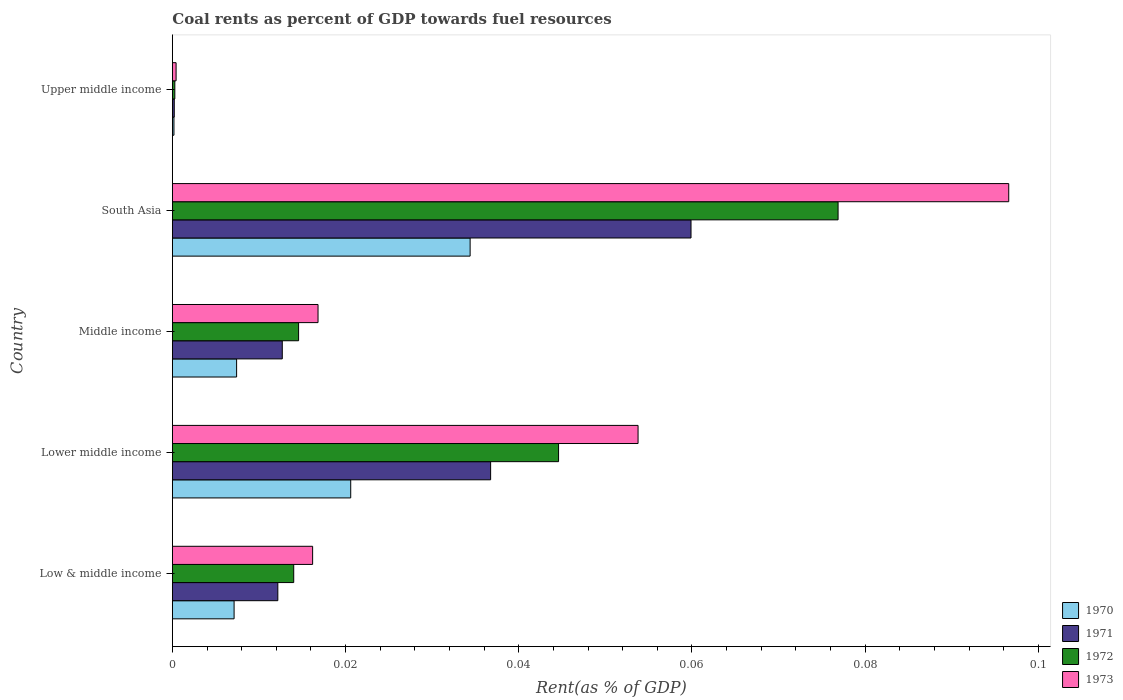Are the number of bars on each tick of the Y-axis equal?
Keep it short and to the point. Yes. How many bars are there on the 5th tick from the top?
Provide a short and direct response. 4. How many bars are there on the 1st tick from the bottom?
Provide a short and direct response. 4. What is the label of the 4th group of bars from the top?
Offer a terse response. Lower middle income. In how many cases, is the number of bars for a given country not equal to the number of legend labels?
Make the answer very short. 0. What is the coal rent in 1970 in Middle income?
Offer a terse response. 0.01. Across all countries, what is the maximum coal rent in 1973?
Provide a succinct answer. 0.1. Across all countries, what is the minimum coal rent in 1970?
Offer a very short reply. 0. In which country was the coal rent in 1971 maximum?
Offer a very short reply. South Asia. In which country was the coal rent in 1973 minimum?
Make the answer very short. Upper middle income. What is the total coal rent in 1973 in the graph?
Offer a very short reply. 0.18. What is the difference between the coal rent in 1971 in South Asia and that in Upper middle income?
Keep it short and to the point. 0.06. What is the difference between the coal rent in 1973 in Lower middle income and the coal rent in 1970 in Middle income?
Keep it short and to the point. 0.05. What is the average coal rent in 1970 per country?
Provide a short and direct response. 0.01. What is the difference between the coal rent in 1971 and coal rent in 1970 in Low & middle income?
Provide a succinct answer. 0.01. In how many countries, is the coal rent in 1971 greater than 0.008 %?
Your answer should be very brief. 4. What is the ratio of the coal rent in 1973 in Low & middle income to that in Lower middle income?
Make the answer very short. 0.3. What is the difference between the highest and the second highest coal rent in 1970?
Your answer should be compact. 0.01. What is the difference between the highest and the lowest coal rent in 1970?
Your response must be concise. 0.03. Is it the case that in every country, the sum of the coal rent in 1973 and coal rent in 1970 is greater than the sum of coal rent in 1971 and coal rent in 1972?
Keep it short and to the point. No. What does the 1st bar from the bottom in Upper middle income represents?
Your answer should be very brief. 1970. What is the difference between two consecutive major ticks on the X-axis?
Your answer should be very brief. 0.02. Does the graph contain any zero values?
Keep it short and to the point. No. Does the graph contain grids?
Your answer should be compact. No. Where does the legend appear in the graph?
Give a very brief answer. Bottom right. How many legend labels are there?
Your answer should be compact. 4. What is the title of the graph?
Your answer should be very brief. Coal rents as percent of GDP towards fuel resources. Does "2005" appear as one of the legend labels in the graph?
Your answer should be very brief. No. What is the label or title of the X-axis?
Make the answer very short. Rent(as % of GDP). What is the Rent(as % of GDP) of 1970 in Low & middle income?
Ensure brevity in your answer.  0.01. What is the Rent(as % of GDP) of 1971 in Low & middle income?
Your answer should be compact. 0.01. What is the Rent(as % of GDP) in 1972 in Low & middle income?
Your response must be concise. 0.01. What is the Rent(as % of GDP) in 1973 in Low & middle income?
Provide a short and direct response. 0.02. What is the Rent(as % of GDP) of 1970 in Lower middle income?
Your answer should be very brief. 0.02. What is the Rent(as % of GDP) in 1971 in Lower middle income?
Your answer should be compact. 0.04. What is the Rent(as % of GDP) of 1972 in Lower middle income?
Offer a very short reply. 0.04. What is the Rent(as % of GDP) of 1973 in Lower middle income?
Offer a terse response. 0.05. What is the Rent(as % of GDP) in 1970 in Middle income?
Give a very brief answer. 0.01. What is the Rent(as % of GDP) of 1971 in Middle income?
Provide a short and direct response. 0.01. What is the Rent(as % of GDP) of 1972 in Middle income?
Offer a very short reply. 0.01. What is the Rent(as % of GDP) in 1973 in Middle income?
Keep it short and to the point. 0.02. What is the Rent(as % of GDP) of 1970 in South Asia?
Your answer should be very brief. 0.03. What is the Rent(as % of GDP) in 1971 in South Asia?
Your response must be concise. 0.06. What is the Rent(as % of GDP) in 1972 in South Asia?
Make the answer very short. 0.08. What is the Rent(as % of GDP) in 1973 in South Asia?
Your response must be concise. 0.1. What is the Rent(as % of GDP) in 1970 in Upper middle income?
Keep it short and to the point. 0. What is the Rent(as % of GDP) in 1971 in Upper middle income?
Provide a short and direct response. 0. What is the Rent(as % of GDP) in 1972 in Upper middle income?
Your response must be concise. 0. What is the Rent(as % of GDP) in 1973 in Upper middle income?
Offer a very short reply. 0. Across all countries, what is the maximum Rent(as % of GDP) of 1970?
Your response must be concise. 0.03. Across all countries, what is the maximum Rent(as % of GDP) in 1971?
Keep it short and to the point. 0.06. Across all countries, what is the maximum Rent(as % of GDP) of 1972?
Offer a very short reply. 0.08. Across all countries, what is the maximum Rent(as % of GDP) in 1973?
Offer a very short reply. 0.1. Across all countries, what is the minimum Rent(as % of GDP) of 1970?
Offer a very short reply. 0. Across all countries, what is the minimum Rent(as % of GDP) of 1971?
Offer a very short reply. 0. Across all countries, what is the minimum Rent(as % of GDP) in 1972?
Your answer should be compact. 0. Across all countries, what is the minimum Rent(as % of GDP) of 1973?
Offer a very short reply. 0. What is the total Rent(as % of GDP) of 1970 in the graph?
Your answer should be very brief. 0.07. What is the total Rent(as % of GDP) of 1971 in the graph?
Provide a short and direct response. 0.12. What is the total Rent(as % of GDP) of 1972 in the graph?
Offer a terse response. 0.15. What is the total Rent(as % of GDP) in 1973 in the graph?
Offer a very short reply. 0.18. What is the difference between the Rent(as % of GDP) of 1970 in Low & middle income and that in Lower middle income?
Provide a short and direct response. -0.01. What is the difference between the Rent(as % of GDP) of 1971 in Low & middle income and that in Lower middle income?
Offer a terse response. -0.02. What is the difference between the Rent(as % of GDP) of 1972 in Low & middle income and that in Lower middle income?
Provide a short and direct response. -0.03. What is the difference between the Rent(as % of GDP) of 1973 in Low & middle income and that in Lower middle income?
Give a very brief answer. -0.04. What is the difference between the Rent(as % of GDP) of 1970 in Low & middle income and that in Middle income?
Provide a short and direct response. -0. What is the difference between the Rent(as % of GDP) of 1971 in Low & middle income and that in Middle income?
Your answer should be compact. -0. What is the difference between the Rent(as % of GDP) in 1972 in Low & middle income and that in Middle income?
Ensure brevity in your answer.  -0. What is the difference between the Rent(as % of GDP) of 1973 in Low & middle income and that in Middle income?
Make the answer very short. -0. What is the difference between the Rent(as % of GDP) in 1970 in Low & middle income and that in South Asia?
Give a very brief answer. -0.03. What is the difference between the Rent(as % of GDP) of 1971 in Low & middle income and that in South Asia?
Your answer should be compact. -0.05. What is the difference between the Rent(as % of GDP) in 1972 in Low & middle income and that in South Asia?
Give a very brief answer. -0.06. What is the difference between the Rent(as % of GDP) of 1973 in Low & middle income and that in South Asia?
Make the answer very short. -0.08. What is the difference between the Rent(as % of GDP) of 1970 in Low & middle income and that in Upper middle income?
Ensure brevity in your answer.  0.01. What is the difference between the Rent(as % of GDP) in 1971 in Low & middle income and that in Upper middle income?
Make the answer very short. 0.01. What is the difference between the Rent(as % of GDP) in 1972 in Low & middle income and that in Upper middle income?
Provide a short and direct response. 0.01. What is the difference between the Rent(as % of GDP) in 1973 in Low & middle income and that in Upper middle income?
Your response must be concise. 0.02. What is the difference between the Rent(as % of GDP) of 1970 in Lower middle income and that in Middle income?
Keep it short and to the point. 0.01. What is the difference between the Rent(as % of GDP) of 1971 in Lower middle income and that in Middle income?
Give a very brief answer. 0.02. What is the difference between the Rent(as % of GDP) in 1973 in Lower middle income and that in Middle income?
Your answer should be very brief. 0.04. What is the difference between the Rent(as % of GDP) of 1970 in Lower middle income and that in South Asia?
Offer a terse response. -0.01. What is the difference between the Rent(as % of GDP) of 1971 in Lower middle income and that in South Asia?
Ensure brevity in your answer.  -0.02. What is the difference between the Rent(as % of GDP) of 1972 in Lower middle income and that in South Asia?
Offer a terse response. -0.03. What is the difference between the Rent(as % of GDP) in 1973 in Lower middle income and that in South Asia?
Provide a short and direct response. -0.04. What is the difference between the Rent(as % of GDP) in 1970 in Lower middle income and that in Upper middle income?
Your answer should be very brief. 0.02. What is the difference between the Rent(as % of GDP) of 1971 in Lower middle income and that in Upper middle income?
Keep it short and to the point. 0.04. What is the difference between the Rent(as % of GDP) of 1972 in Lower middle income and that in Upper middle income?
Provide a succinct answer. 0.04. What is the difference between the Rent(as % of GDP) of 1973 in Lower middle income and that in Upper middle income?
Make the answer very short. 0.05. What is the difference between the Rent(as % of GDP) in 1970 in Middle income and that in South Asia?
Keep it short and to the point. -0.03. What is the difference between the Rent(as % of GDP) in 1971 in Middle income and that in South Asia?
Your answer should be very brief. -0.05. What is the difference between the Rent(as % of GDP) in 1972 in Middle income and that in South Asia?
Your answer should be very brief. -0.06. What is the difference between the Rent(as % of GDP) of 1973 in Middle income and that in South Asia?
Give a very brief answer. -0.08. What is the difference between the Rent(as % of GDP) in 1970 in Middle income and that in Upper middle income?
Your answer should be compact. 0.01. What is the difference between the Rent(as % of GDP) of 1971 in Middle income and that in Upper middle income?
Your answer should be very brief. 0.01. What is the difference between the Rent(as % of GDP) in 1972 in Middle income and that in Upper middle income?
Your response must be concise. 0.01. What is the difference between the Rent(as % of GDP) of 1973 in Middle income and that in Upper middle income?
Provide a succinct answer. 0.02. What is the difference between the Rent(as % of GDP) of 1970 in South Asia and that in Upper middle income?
Provide a succinct answer. 0.03. What is the difference between the Rent(as % of GDP) in 1971 in South Asia and that in Upper middle income?
Give a very brief answer. 0.06. What is the difference between the Rent(as % of GDP) of 1972 in South Asia and that in Upper middle income?
Provide a short and direct response. 0.08. What is the difference between the Rent(as % of GDP) of 1973 in South Asia and that in Upper middle income?
Your answer should be compact. 0.1. What is the difference between the Rent(as % of GDP) of 1970 in Low & middle income and the Rent(as % of GDP) of 1971 in Lower middle income?
Make the answer very short. -0.03. What is the difference between the Rent(as % of GDP) in 1970 in Low & middle income and the Rent(as % of GDP) in 1972 in Lower middle income?
Your answer should be compact. -0.04. What is the difference between the Rent(as % of GDP) of 1970 in Low & middle income and the Rent(as % of GDP) of 1973 in Lower middle income?
Your answer should be very brief. -0.05. What is the difference between the Rent(as % of GDP) of 1971 in Low & middle income and the Rent(as % of GDP) of 1972 in Lower middle income?
Keep it short and to the point. -0.03. What is the difference between the Rent(as % of GDP) of 1971 in Low & middle income and the Rent(as % of GDP) of 1973 in Lower middle income?
Offer a very short reply. -0.04. What is the difference between the Rent(as % of GDP) of 1972 in Low & middle income and the Rent(as % of GDP) of 1973 in Lower middle income?
Provide a succinct answer. -0.04. What is the difference between the Rent(as % of GDP) of 1970 in Low & middle income and the Rent(as % of GDP) of 1971 in Middle income?
Provide a short and direct response. -0.01. What is the difference between the Rent(as % of GDP) in 1970 in Low & middle income and the Rent(as % of GDP) in 1972 in Middle income?
Keep it short and to the point. -0.01. What is the difference between the Rent(as % of GDP) of 1970 in Low & middle income and the Rent(as % of GDP) of 1973 in Middle income?
Your answer should be very brief. -0.01. What is the difference between the Rent(as % of GDP) of 1971 in Low & middle income and the Rent(as % of GDP) of 1972 in Middle income?
Keep it short and to the point. -0. What is the difference between the Rent(as % of GDP) of 1971 in Low & middle income and the Rent(as % of GDP) of 1973 in Middle income?
Offer a terse response. -0. What is the difference between the Rent(as % of GDP) of 1972 in Low & middle income and the Rent(as % of GDP) of 1973 in Middle income?
Offer a very short reply. -0. What is the difference between the Rent(as % of GDP) of 1970 in Low & middle income and the Rent(as % of GDP) of 1971 in South Asia?
Your response must be concise. -0.05. What is the difference between the Rent(as % of GDP) of 1970 in Low & middle income and the Rent(as % of GDP) of 1972 in South Asia?
Your response must be concise. -0.07. What is the difference between the Rent(as % of GDP) in 1970 in Low & middle income and the Rent(as % of GDP) in 1973 in South Asia?
Your answer should be very brief. -0.09. What is the difference between the Rent(as % of GDP) in 1971 in Low & middle income and the Rent(as % of GDP) in 1972 in South Asia?
Your answer should be very brief. -0.06. What is the difference between the Rent(as % of GDP) in 1971 in Low & middle income and the Rent(as % of GDP) in 1973 in South Asia?
Your answer should be compact. -0.08. What is the difference between the Rent(as % of GDP) in 1972 in Low & middle income and the Rent(as % of GDP) in 1973 in South Asia?
Your answer should be compact. -0.08. What is the difference between the Rent(as % of GDP) of 1970 in Low & middle income and the Rent(as % of GDP) of 1971 in Upper middle income?
Your answer should be very brief. 0.01. What is the difference between the Rent(as % of GDP) of 1970 in Low & middle income and the Rent(as % of GDP) of 1972 in Upper middle income?
Provide a short and direct response. 0.01. What is the difference between the Rent(as % of GDP) in 1970 in Low & middle income and the Rent(as % of GDP) in 1973 in Upper middle income?
Your response must be concise. 0.01. What is the difference between the Rent(as % of GDP) of 1971 in Low & middle income and the Rent(as % of GDP) of 1972 in Upper middle income?
Offer a very short reply. 0.01. What is the difference between the Rent(as % of GDP) of 1971 in Low & middle income and the Rent(as % of GDP) of 1973 in Upper middle income?
Your response must be concise. 0.01. What is the difference between the Rent(as % of GDP) of 1972 in Low & middle income and the Rent(as % of GDP) of 1973 in Upper middle income?
Your response must be concise. 0.01. What is the difference between the Rent(as % of GDP) in 1970 in Lower middle income and the Rent(as % of GDP) in 1971 in Middle income?
Provide a short and direct response. 0.01. What is the difference between the Rent(as % of GDP) of 1970 in Lower middle income and the Rent(as % of GDP) of 1972 in Middle income?
Your response must be concise. 0.01. What is the difference between the Rent(as % of GDP) of 1970 in Lower middle income and the Rent(as % of GDP) of 1973 in Middle income?
Ensure brevity in your answer.  0. What is the difference between the Rent(as % of GDP) in 1971 in Lower middle income and the Rent(as % of GDP) in 1972 in Middle income?
Provide a short and direct response. 0.02. What is the difference between the Rent(as % of GDP) of 1971 in Lower middle income and the Rent(as % of GDP) of 1973 in Middle income?
Your answer should be very brief. 0.02. What is the difference between the Rent(as % of GDP) of 1972 in Lower middle income and the Rent(as % of GDP) of 1973 in Middle income?
Offer a terse response. 0.03. What is the difference between the Rent(as % of GDP) in 1970 in Lower middle income and the Rent(as % of GDP) in 1971 in South Asia?
Offer a terse response. -0.04. What is the difference between the Rent(as % of GDP) of 1970 in Lower middle income and the Rent(as % of GDP) of 1972 in South Asia?
Offer a very short reply. -0.06. What is the difference between the Rent(as % of GDP) in 1970 in Lower middle income and the Rent(as % of GDP) in 1973 in South Asia?
Your response must be concise. -0.08. What is the difference between the Rent(as % of GDP) in 1971 in Lower middle income and the Rent(as % of GDP) in 1972 in South Asia?
Ensure brevity in your answer.  -0.04. What is the difference between the Rent(as % of GDP) in 1971 in Lower middle income and the Rent(as % of GDP) in 1973 in South Asia?
Give a very brief answer. -0.06. What is the difference between the Rent(as % of GDP) of 1972 in Lower middle income and the Rent(as % of GDP) of 1973 in South Asia?
Ensure brevity in your answer.  -0.05. What is the difference between the Rent(as % of GDP) in 1970 in Lower middle income and the Rent(as % of GDP) in 1971 in Upper middle income?
Provide a succinct answer. 0.02. What is the difference between the Rent(as % of GDP) in 1970 in Lower middle income and the Rent(as % of GDP) in 1972 in Upper middle income?
Give a very brief answer. 0.02. What is the difference between the Rent(as % of GDP) in 1970 in Lower middle income and the Rent(as % of GDP) in 1973 in Upper middle income?
Your answer should be very brief. 0.02. What is the difference between the Rent(as % of GDP) in 1971 in Lower middle income and the Rent(as % of GDP) in 1972 in Upper middle income?
Your answer should be very brief. 0.04. What is the difference between the Rent(as % of GDP) of 1971 in Lower middle income and the Rent(as % of GDP) of 1973 in Upper middle income?
Provide a short and direct response. 0.04. What is the difference between the Rent(as % of GDP) of 1972 in Lower middle income and the Rent(as % of GDP) of 1973 in Upper middle income?
Offer a terse response. 0.04. What is the difference between the Rent(as % of GDP) of 1970 in Middle income and the Rent(as % of GDP) of 1971 in South Asia?
Keep it short and to the point. -0.05. What is the difference between the Rent(as % of GDP) of 1970 in Middle income and the Rent(as % of GDP) of 1972 in South Asia?
Ensure brevity in your answer.  -0.07. What is the difference between the Rent(as % of GDP) of 1970 in Middle income and the Rent(as % of GDP) of 1973 in South Asia?
Provide a succinct answer. -0.09. What is the difference between the Rent(as % of GDP) of 1971 in Middle income and the Rent(as % of GDP) of 1972 in South Asia?
Provide a succinct answer. -0.06. What is the difference between the Rent(as % of GDP) in 1971 in Middle income and the Rent(as % of GDP) in 1973 in South Asia?
Offer a terse response. -0.08. What is the difference between the Rent(as % of GDP) in 1972 in Middle income and the Rent(as % of GDP) in 1973 in South Asia?
Provide a short and direct response. -0.08. What is the difference between the Rent(as % of GDP) in 1970 in Middle income and the Rent(as % of GDP) in 1971 in Upper middle income?
Your response must be concise. 0.01. What is the difference between the Rent(as % of GDP) in 1970 in Middle income and the Rent(as % of GDP) in 1972 in Upper middle income?
Your response must be concise. 0.01. What is the difference between the Rent(as % of GDP) of 1970 in Middle income and the Rent(as % of GDP) of 1973 in Upper middle income?
Give a very brief answer. 0.01. What is the difference between the Rent(as % of GDP) of 1971 in Middle income and the Rent(as % of GDP) of 1972 in Upper middle income?
Offer a very short reply. 0.01. What is the difference between the Rent(as % of GDP) of 1971 in Middle income and the Rent(as % of GDP) of 1973 in Upper middle income?
Offer a very short reply. 0.01. What is the difference between the Rent(as % of GDP) in 1972 in Middle income and the Rent(as % of GDP) in 1973 in Upper middle income?
Ensure brevity in your answer.  0.01. What is the difference between the Rent(as % of GDP) in 1970 in South Asia and the Rent(as % of GDP) in 1971 in Upper middle income?
Your answer should be compact. 0.03. What is the difference between the Rent(as % of GDP) in 1970 in South Asia and the Rent(as % of GDP) in 1972 in Upper middle income?
Keep it short and to the point. 0.03. What is the difference between the Rent(as % of GDP) in 1970 in South Asia and the Rent(as % of GDP) in 1973 in Upper middle income?
Give a very brief answer. 0.03. What is the difference between the Rent(as % of GDP) of 1971 in South Asia and the Rent(as % of GDP) of 1972 in Upper middle income?
Keep it short and to the point. 0.06. What is the difference between the Rent(as % of GDP) of 1971 in South Asia and the Rent(as % of GDP) of 1973 in Upper middle income?
Provide a succinct answer. 0.06. What is the difference between the Rent(as % of GDP) of 1972 in South Asia and the Rent(as % of GDP) of 1973 in Upper middle income?
Offer a very short reply. 0.08. What is the average Rent(as % of GDP) in 1970 per country?
Make the answer very short. 0.01. What is the average Rent(as % of GDP) in 1971 per country?
Your response must be concise. 0.02. What is the average Rent(as % of GDP) of 1972 per country?
Give a very brief answer. 0.03. What is the average Rent(as % of GDP) in 1973 per country?
Ensure brevity in your answer.  0.04. What is the difference between the Rent(as % of GDP) in 1970 and Rent(as % of GDP) in 1971 in Low & middle income?
Provide a short and direct response. -0.01. What is the difference between the Rent(as % of GDP) in 1970 and Rent(as % of GDP) in 1972 in Low & middle income?
Offer a terse response. -0.01. What is the difference between the Rent(as % of GDP) in 1970 and Rent(as % of GDP) in 1973 in Low & middle income?
Keep it short and to the point. -0.01. What is the difference between the Rent(as % of GDP) of 1971 and Rent(as % of GDP) of 1972 in Low & middle income?
Ensure brevity in your answer.  -0. What is the difference between the Rent(as % of GDP) of 1971 and Rent(as % of GDP) of 1973 in Low & middle income?
Make the answer very short. -0. What is the difference between the Rent(as % of GDP) in 1972 and Rent(as % of GDP) in 1973 in Low & middle income?
Keep it short and to the point. -0. What is the difference between the Rent(as % of GDP) of 1970 and Rent(as % of GDP) of 1971 in Lower middle income?
Offer a very short reply. -0.02. What is the difference between the Rent(as % of GDP) of 1970 and Rent(as % of GDP) of 1972 in Lower middle income?
Offer a terse response. -0.02. What is the difference between the Rent(as % of GDP) of 1970 and Rent(as % of GDP) of 1973 in Lower middle income?
Your response must be concise. -0.03. What is the difference between the Rent(as % of GDP) of 1971 and Rent(as % of GDP) of 1972 in Lower middle income?
Make the answer very short. -0.01. What is the difference between the Rent(as % of GDP) of 1971 and Rent(as % of GDP) of 1973 in Lower middle income?
Make the answer very short. -0.02. What is the difference between the Rent(as % of GDP) in 1972 and Rent(as % of GDP) in 1973 in Lower middle income?
Offer a terse response. -0.01. What is the difference between the Rent(as % of GDP) of 1970 and Rent(as % of GDP) of 1971 in Middle income?
Offer a very short reply. -0.01. What is the difference between the Rent(as % of GDP) of 1970 and Rent(as % of GDP) of 1972 in Middle income?
Your answer should be compact. -0.01. What is the difference between the Rent(as % of GDP) of 1970 and Rent(as % of GDP) of 1973 in Middle income?
Keep it short and to the point. -0.01. What is the difference between the Rent(as % of GDP) in 1971 and Rent(as % of GDP) in 1972 in Middle income?
Keep it short and to the point. -0. What is the difference between the Rent(as % of GDP) of 1971 and Rent(as % of GDP) of 1973 in Middle income?
Give a very brief answer. -0. What is the difference between the Rent(as % of GDP) of 1972 and Rent(as % of GDP) of 1973 in Middle income?
Keep it short and to the point. -0. What is the difference between the Rent(as % of GDP) of 1970 and Rent(as % of GDP) of 1971 in South Asia?
Make the answer very short. -0.03. What is the difference between the Rent(as % of GDP) in 1970 and Rent(as % of GDP) in 1972 in South Asia?
Offer a terse response. -0.04. What is the difference between the Rent(as % of GDP) in 1970 and Rent(as % of GDP) in 1973 in South Asia?
Provide a short and direct response. -0.06. What is the difference between the Rent(as % of GDP) in 1971 and Rent(as % of GDP) in 1972 in South Asia?
Provide a succinct answer. -0.02. What is the difference between the Rent(as % of GDP) of 1971 and Rent(as % of GDP) of 1973 in South Asia?
Make the answer very short. -0.04. What is the difference between the Rent(as % of GDP) of 1972 and Rent(as % of GDP) of 1973 in South Asia?
Provide a short and direct response. -0.02. What is the difference between the Rent(as % of GDP) in 1970 and Rent(as % of GDP) in 1971 in Upper middle income?
Offer a terse response. -0. What is the difference between the Rent(as % of GDP) in 1970 and Rent(as % of GDP) in 1972 in Upper middle income?
Keep it short and to the point. -0. What is the difference between the Rent(as % of GDP) of 1970 and Rent(as % of GDP) of 1973 in Upper middle income?
Ensure brevity in your answer.  -0. What is the difference between the Rent(as % of GDP) of 1971 and Rent(as % of GDP) of 1972 in Upper middle income?
Your response must be concise. -0. What is the difference between the Rent(as % of GDP) in 1971 and Rent(as % of GDP) in 1973 in Upper middle income?
Your answer should be compact. -0. What is the difference between the Rent(as % of GDP) in 1972 and Rent(as % of GDP) in 1973 in Upper middle income?
Give a very brief answer. -0. What is the ratio of the Rent(as % of GDP) of 1970 in Low & middle income to that in Lower middle income?
Offer a very short reply. 0.35. What is the ratio of the Rent(as % of GDP) of 1971 in Low & middle income to that in Lower middle income?
Provide a succinct answer. 0.33. What is the ratio of the Rent(as % of GDP) in 1972 in Low & middle income to that in Lower middle income?
Ensure brevity in your answer.  0.31. What is the ratio of the Rent(as % of GDP) of 1973 in Low & middle income to that in Lower middle income?
Provide a short and direct response. 0.3. What is the ratio of the Rent(as % of GDP) of 1970 in Low & middle income to that in Middle income?
Give a very brief answer. 0.96. What is the ratio of the Rent(as % of GDP) in 1971 in Low & middle income to that in Middle income?
Your answer should be very brief. 0.96. What is the ratio of the Rent(as % of GDP) of 1972 in Low & middle income to that in Middle income?
Your answer should be compact. 0.96. What is the ratio of the Rent(as % of GDP) of 1973 in Low & middle income to that in Middle income?
Make the answer very short. 0.96. What is the ratio of the Rent(as % of GDP) in 1970 in Low & middle income to that in South Asia?
Provide a succinct answer. 0.21. What is the ratio of the Rent(as % of GDP) in 1971 in Low & middle income to that in South Asia?
Offer a very short reply. 0.2. What is the ratio of the Rent(as % of GDP) in 1972 in Low & middle income to that in South Asia?
Offer a very short reply. 0.18. What is the ratio of the Rent(as % of GDP) in 1973 in Low & middle income to that in South Asia?
Make the answer very short. 0.17. What is the ratio of the Rent(as % of GDP) in 1970 in Low & middle income to that in Upper middle income?
Offer a very short reply. 38.77. What is the ratio of the Rent(as % of GDP) of 1971 in Low & middle income to that in Upper middle income?
Give a very brief answer. 55.66. What is the ratio of the Rent(as % of GDP) in 1972 in Low & middle income to that in Upper middle income?
Offer a very short reply. 49.28. What is the ratio of the Rent(as % of GDP) of 1973 in Low & middle income to that in Upper middle income?
Offer a terse response. 37.59. What is the ratio of the Rent(as % of GDP) of 1970 in Lower middle income to that in Middle income?
Give a very brief answer. 2.78. What is the ratio of the Rent(as % of GDP) of 1971 in Lower middle income to that in Middle income?
Your answer should be compact. 2.9. What is the ratio of the Rent(as % of GDP) in 1972 in Lower middle income to that in Middle income?
Your answer should be compact. 3.06. What is the ratio of the Rent(as % of GDP) of 1973 in Lower middle income to that in Middle income?
Keep it short and to the point. 3.2. What is the ratio of the Rent(as % of GDP) in 1970 in Lower middle income to that in South Asia?
Ensure brevity in your answer.  0.6. What is the ratio of the Rent(as % of GDP) in 1971 in Lower middle income to that in South Asia?
Offer a very short reply. 0.61. What is the ratio of the Rent(as % of GDP) of 1972 in Lower middle income to that in South Asia?
Provide a short and direct response. 0.58. What is the ratio of the Rent(as % of GDP) in 1973 in Lower middle income to that in South Asia?
Provide a short and direct response. 0.56. What is the ratio of the Rent(as % of GDP) of 1970 in Lower middle income to that in Upper middle income?
Make the answer very short. 112.03. What is the ratio of the Rent(as % of GDP) in 1971 in Lower middle income to that in Upper middle income?
Make the answer very short. 167.98. What is the ratio of the Rent(as % of GDP) of 1972 in Lower middle income to that in Upper middle income?
Your answer should be very brief. 156.82. What is the ratio of the Rent(as % of GDP) of 1973 in Lower middle income to that in Upper middle income?
Offer a very short reply. 124.82. What is the ratio of the Rent(as % of GDP) of 1970 in Middle income to that in South Asia?
Offer a terse response. 0.22. What is the ratio of the Rent(as % of GDP) in 1971 in Middle income to that in South Asia?
Your response must be concise. 0.21. What is the ratio of the Rent(as % of GDP) in 1972 in Middle income to that in South Asia?
Your answer should be compact. 0.19. What is the ratio of the Rent(as % of GDP) in 1973 in Middle income to that in South Asia?
Keep it short and to the point. 0.17. What is the ratio of the Rent(as % of GDP) in 1970 in Middle income to that in Upper middle income?
Offer a very short reply. 40.36. What is the ratio of the Rent(as % of GDP) in 1971 in Middle income to that in Upper middle income?
Keep it short and to the point. 58.01. What is the ratio of the Rent(as % of GDP) of 1972 in Middle income to that in Upper middle income?
Provide a short and direct response. 51.25. What is the ratio of the Rent(as % of GDP) in 1973 in Middle income to that in Upper middle income?
Give a very brief answer. 39.04. What is the ratio of the Rent(as % of GDP) of 1970 in South Asia to that in Upper middle income?
Offer a terse response. 187.05. What is the ratio of the Rent(as % of GDP) of 1971 in South Asia to that in Upper middle income?
Give a very brief answer. 273.74. What is the ratio of the Rent(as % of GDP) in 1972 in South Asia to that in Upper middle income?
Provide a succinct answer. 270.32. What is the ratio of the Rent(as % of GDP) in 1973 in South Asia to that in Upper middle income?
Offer a terse response. 224.18. What is the difference between the highest and the second highest Rent(as % of GDP) in 1970?
Ensure brevity in your answer.  0.01. What is the difference between the highest and the second highest Rent(as % of GDP) of 1971?
Offer a very short reply. 0.02. What is the difference between the highest and the second highest Rent(as % of GDP) of 1972?
Make the answer very short. 0.03. What is the difference between the highest and the second highest Rent(as % of GDP) of 1973?
Give a very brief answer. 0.04. What is the difference between the highest and the lowest Rent(as % of GDP) in 1970?
Your response must be concise. 0.03. What is the difference between the highest and the lowest Rent(as % of GDP) in 1971?
Provide a succinct answer. 0.06. What is the difference between the highest and the lowest Rent(as % of GDP) in 1972?
Give a very brief answer. 0.08. What is the difference between the highest and the lowest Rent(as % of GDP) in 1973?
Your response must be concise. 0.1. 